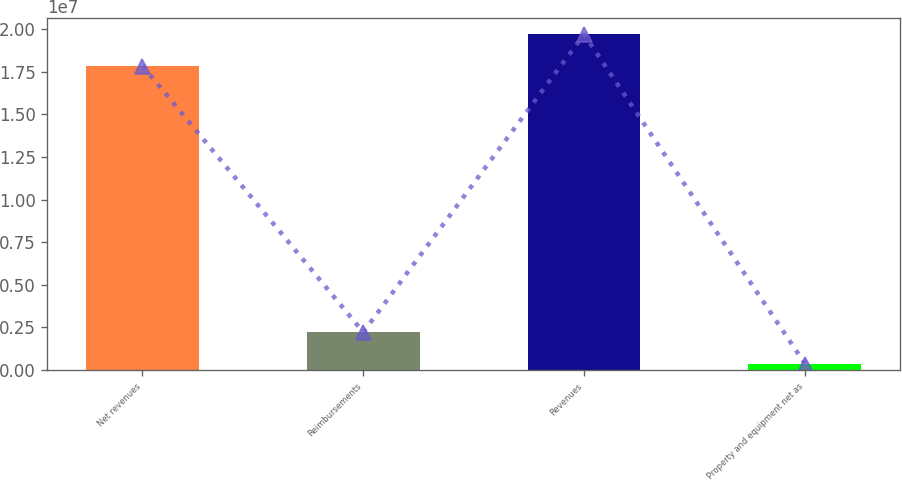Convert chart to OTSL. <chart><loc_0><loc_0><loc_500><loc_500><bar_chart><fcel>Net revenues<fcel>Reimbursements<fcel>Revenues<fcel>Property and equipment net as<nl><fcel>1.7849e+07<fcel>2.21534e+06<fcel>1.96891e+07<fcel>375237<nl></chart> 